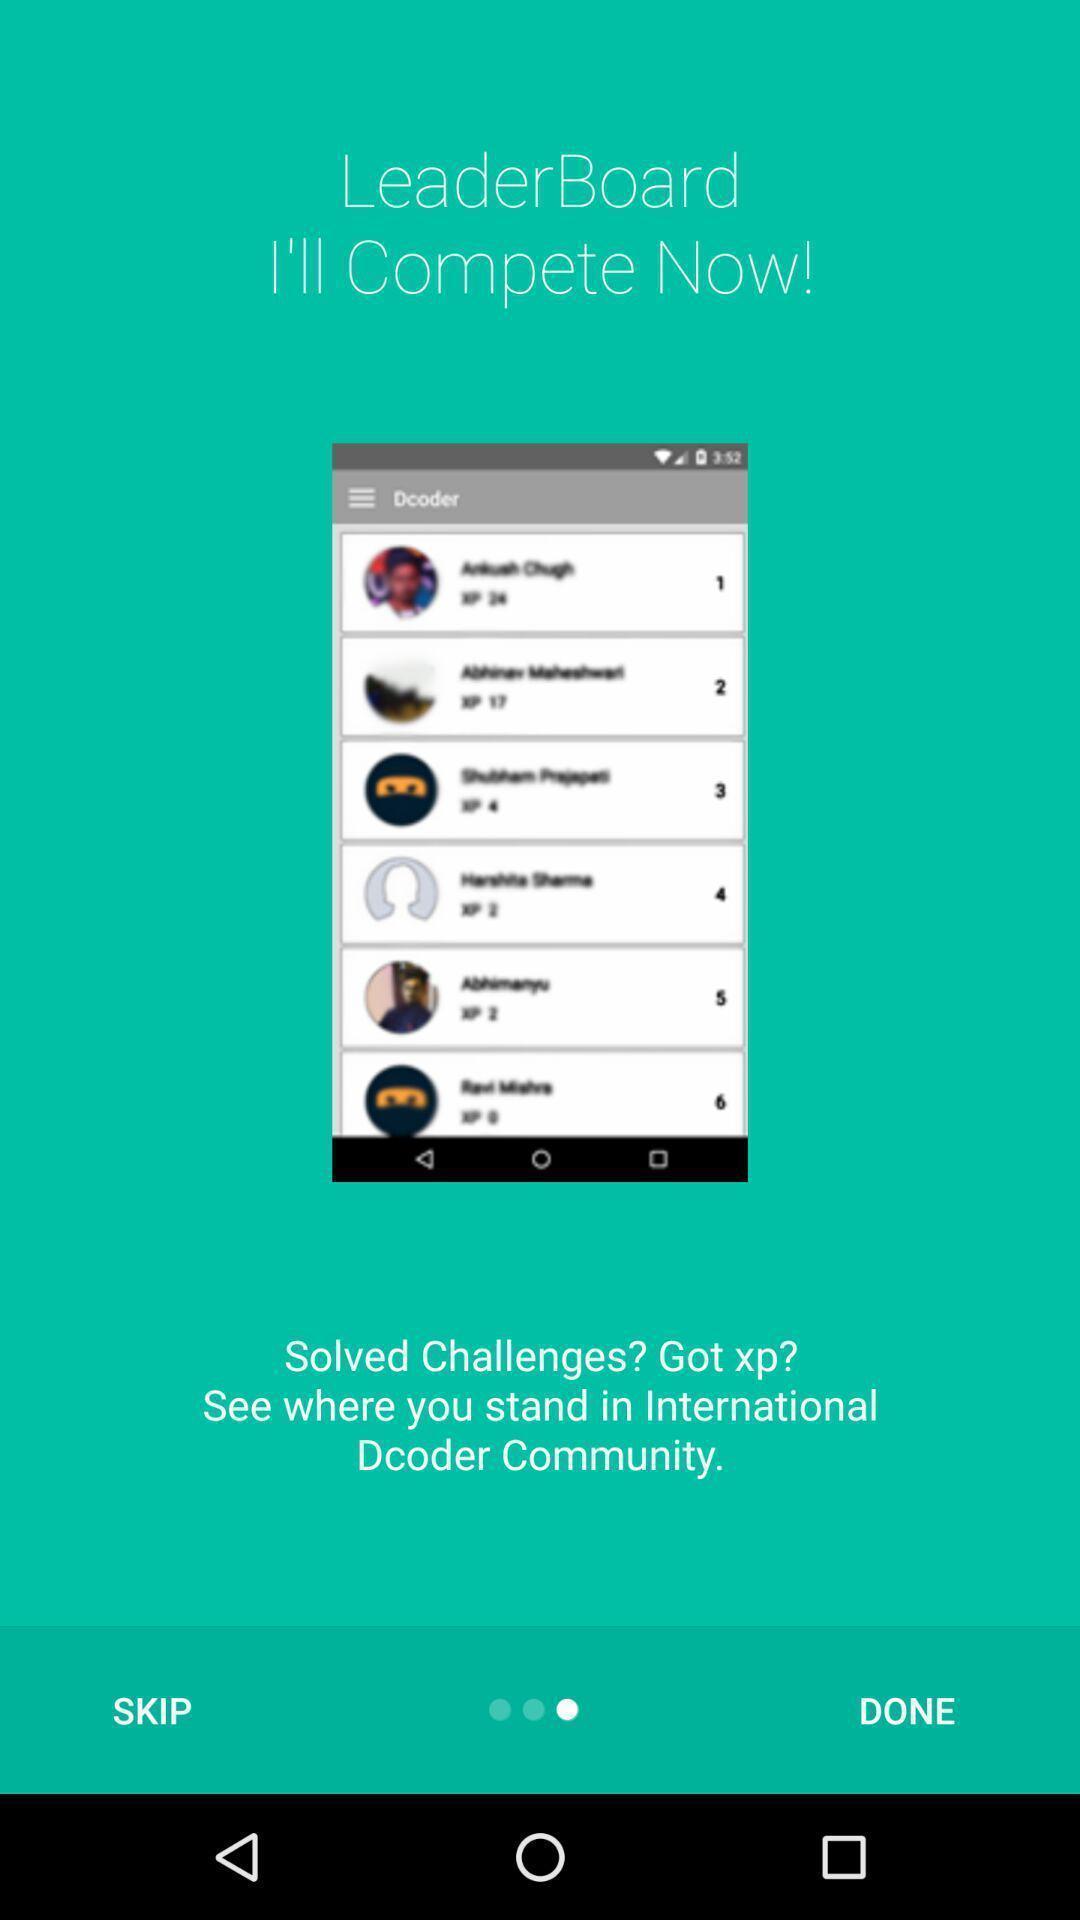Explain what's happening in this screen capture. Welcome page of learning application. 